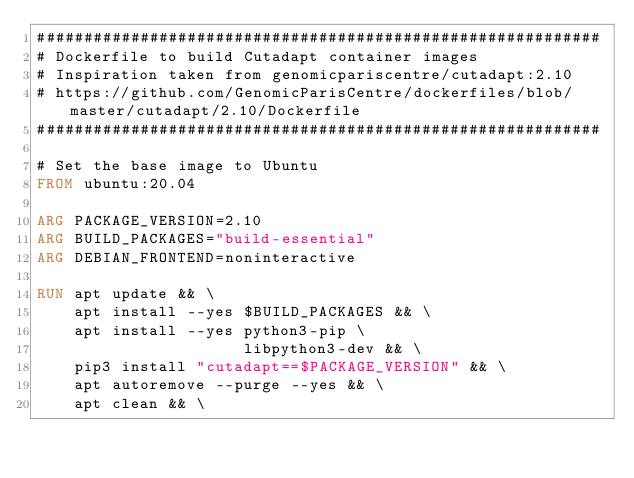<code> <loc_0><loc_0><loc_500><loc_500><_Dockerfile_>############################################################
# Dockerfile to build Cutadapt container images
# Inspiration taken from genomicpariscentre/cutadapt:2.10
# https://github.com/GenomicParisCentre/dockerfiles/blob/master/cutadapt/2.10/Dockerfile
############################################################

# Set the base image to Ubuntu
FROM ubuntu:20.04

ARG PACKAGE_VERSION=2.10
ARG BUILD_PACKAGES="build-essential"
ARG DEBIAN_FRONTEND=noninteractive

RUN apt update && \
    apt install --yes $BUILD_PACKAGES && \
    apt install --yes python3-pip \
                      libpython3-dev && \
    pip3 install "cutadapt==$PACKAGE_VERSION" && \
    apt autoremove --purge --yes && \
    apt clean && \</code> 